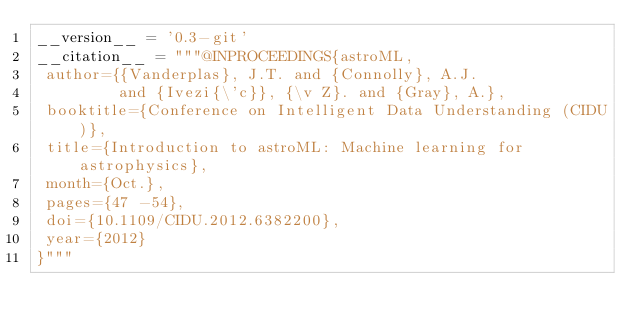<code> <loc_0><loc_0><loc_500><loc_500><_Python_>__version__ = '0.3-git'
__citation__ = """@INPROCEEDINGS{astroML,
 author={{Vanderplas}, J.T. and {Connolly}, A.J.
         and {Ivezi{\'c}}, {\v Z}. and {Gray}, A.},
 booktitle={Conference on Intelligent Data Understanding (CIDU)},
 title={Introduction to astroML: Machine learning for astrophysics},
 month={Oct.},
 pages={47 -54},
 doi={10.1109/CIDU.2012.6382200},
 year={2012}
}"""
</code> 